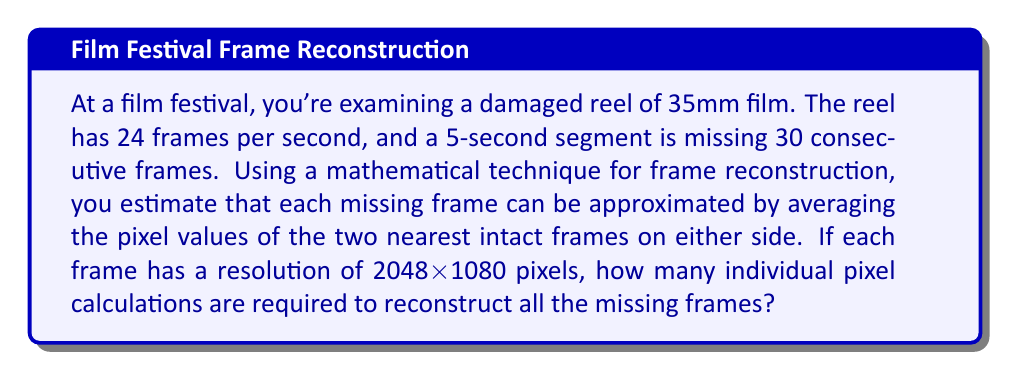Show me your answer to this math problem. Let's break this down step-by-step:

1. First, we need to determine how many frames are missing:
   - The segment is 5 seconds long
   - There are 24 frames per second
   - Total missing frames = 5 * 24 = 120 frames

2. We're told that 30 consecutive frames are missing, so we need to reconstruct these 30 frames.

3. Each frame has a resolution of 2048x1080 pixels:
   - Total pixels per frame = 2048 * 1080 = 2,211,840 pixels

4. For each missing frame, we need to calculate the average of four pixel values (two from the frame before and two from the frame after):
   - Calculations per pixel = 4 (3 additions and 1 division)

5. Total calculations:
   $$\text{Total calculations} = \text{Number of missing frames} \times \text{Pixels per frame} \times \text{Calculations per pixel}$$
   $$\text{Total calculations} = 30 \times 2,211,840 \times 4$$
   $$\text{Total calculations} = 265,420,800$$

Therefore, 265,420,800 individual pixel calculations are required to reconstruct all the missing frames.
Answer: 265,420,800 calculations 